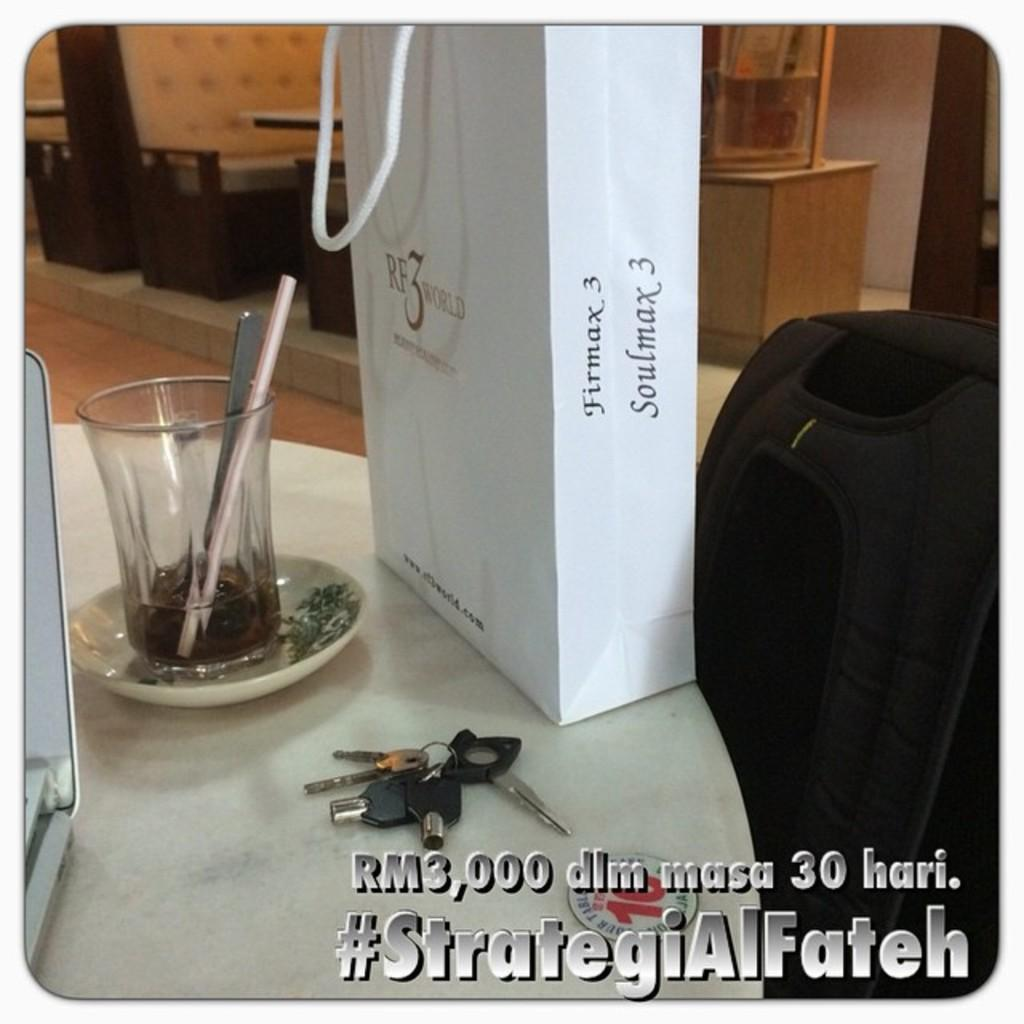<image>
Give a short and clear explanation of the subsequent image. A bag, marked Soulmax 3, is behind a set of keys. 